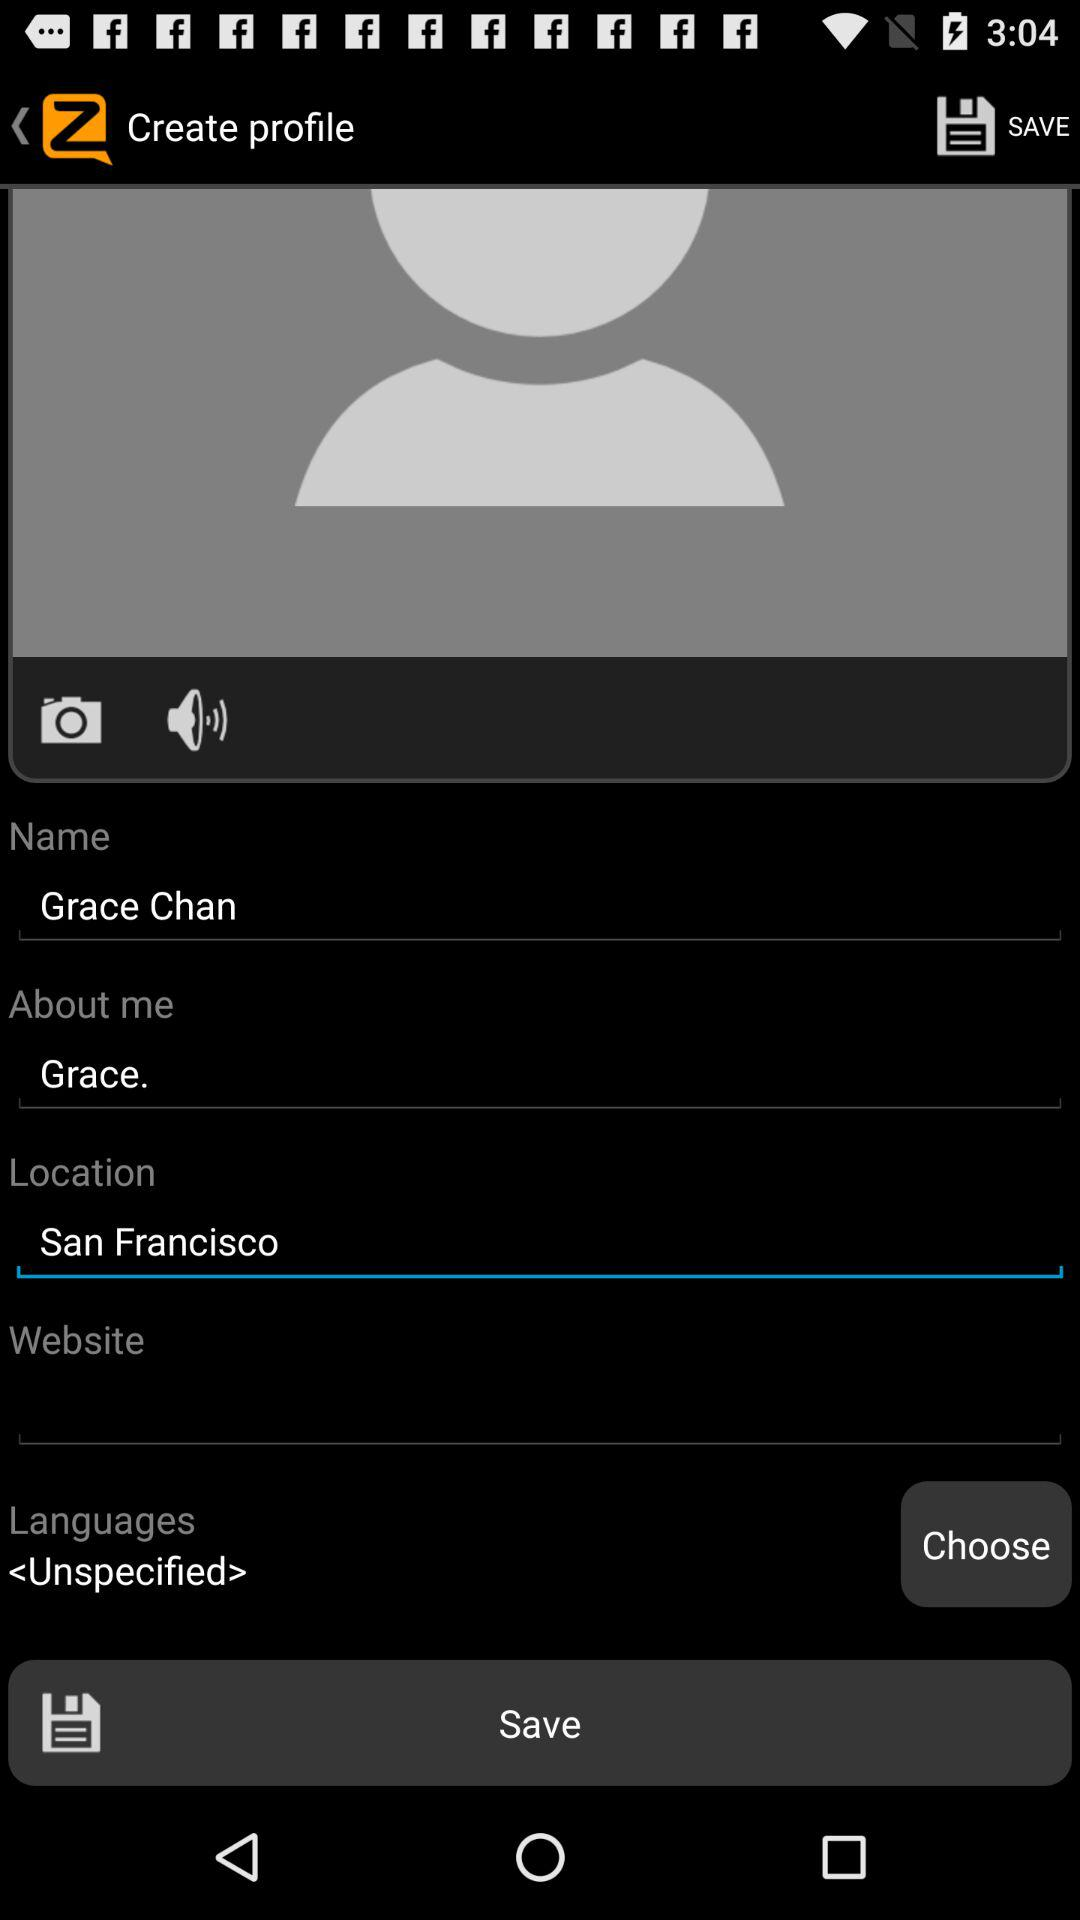What's the location? The location is San Francisco. 